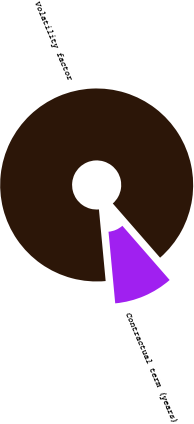<chart> <loc_0><loc_0><loc_500><loc_500><pie_chart><fcel>Volatility factor<fcel>Contractual term (years)<nl><fcel>90.07%<fcel>9.93%<nl></chart> 